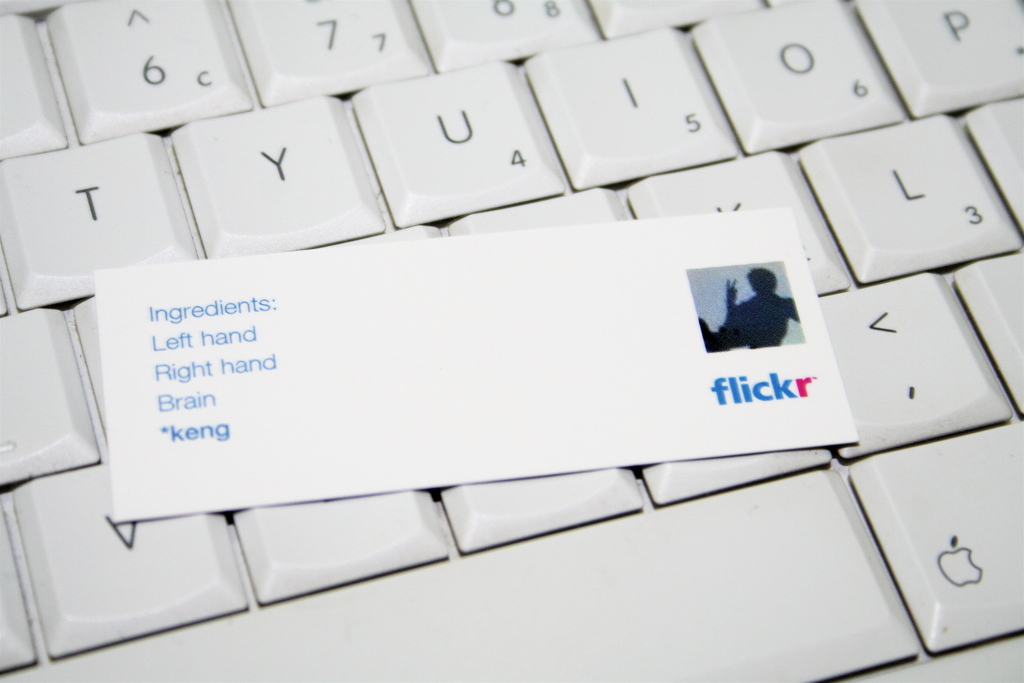How might the concept of using 'left hand', 'right hand', and 'brain' as ingredients inspire someone in a creative field? Using such terms as 'ingredients' metaphorically celebrates the holistic engagement of one's faculties in creative processes. It emphasizes the importance of combining manual dexterity and mental capacities, encouraging individuals to fully utilize their physical and cognitive skills in harmony to innovate or create. This could inspire artists, writers, or developers to think of their work as a blend of varied elements that must work in cohesion, much like ingredients in a recipe. 